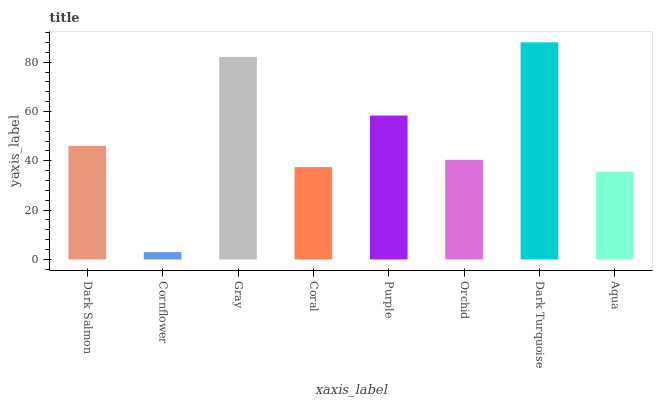Is Cornflower the minimum?
Answer yes or no. Yes. Is Dark Turquoise the maximum?
Answer yes or no. Yes. Is Gray the minimum?
Answer yes or no. No. Is Gray the maximum?
Answer yes or no. No. Is Gray greater than Cornflower?
Answer yes or no. Yes. Is Cornflower less than Gray?
Answer yes or no. Yes. Is Cornflower greater than Gray?
Answer yes or no. No. Is Gray less than Cornflower?
Answer yes or no. No. Is Dark Salmon the high median?
Answer yes or no. Yes. Is Orchid the low median?
Answer yes or no. Yes. Is Cornflower the high median?
Answer yes or no. No. Is Aqua the low median?
Answer yes or no. No. 